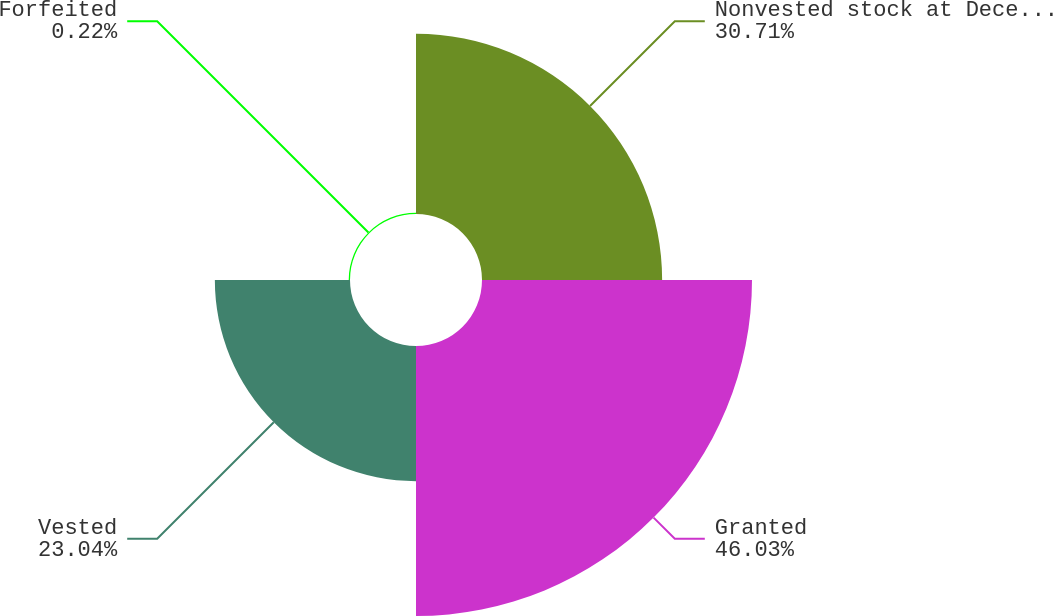<chart> <loc_0><loc_0><loc_500><loc_500><pie_chart><fcel>Nonvested stock at December 31<fcel>Granted<fcel>Vested<fcel>Forfeited<nl><fcel>30.71%<fcel>46.03%<fcel>23.04%<fcel>0.22%<nl></chart> 